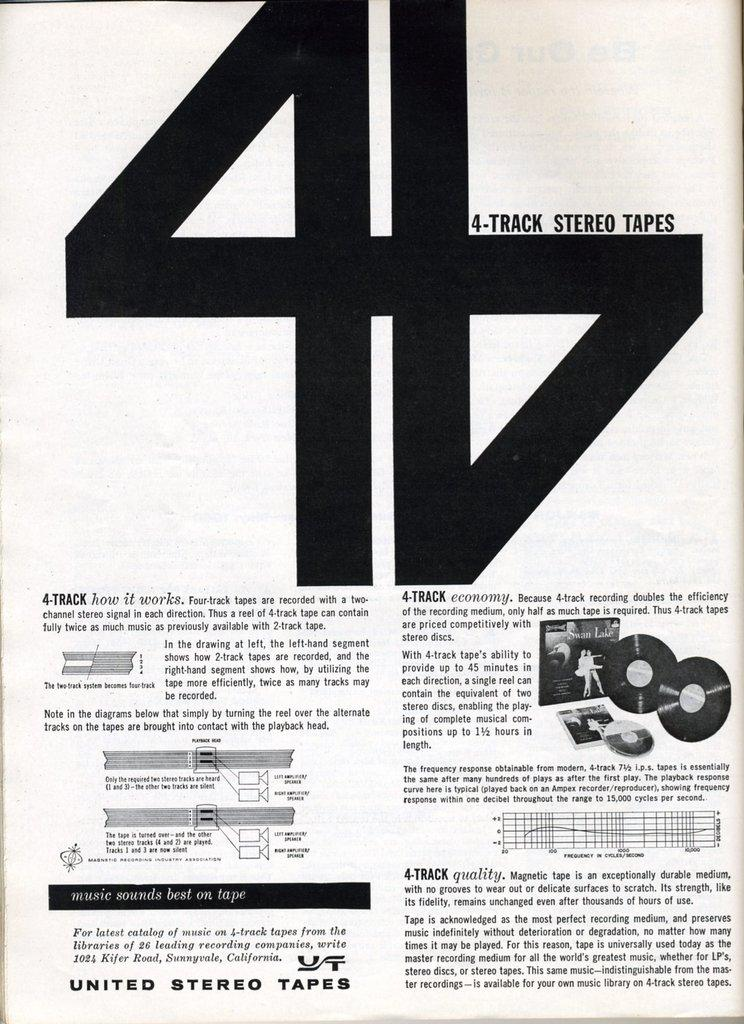Provide a one-sentence caption for the provided image. An instruction sheet for 4-track stereo tapes by United Stereo Tapes. 